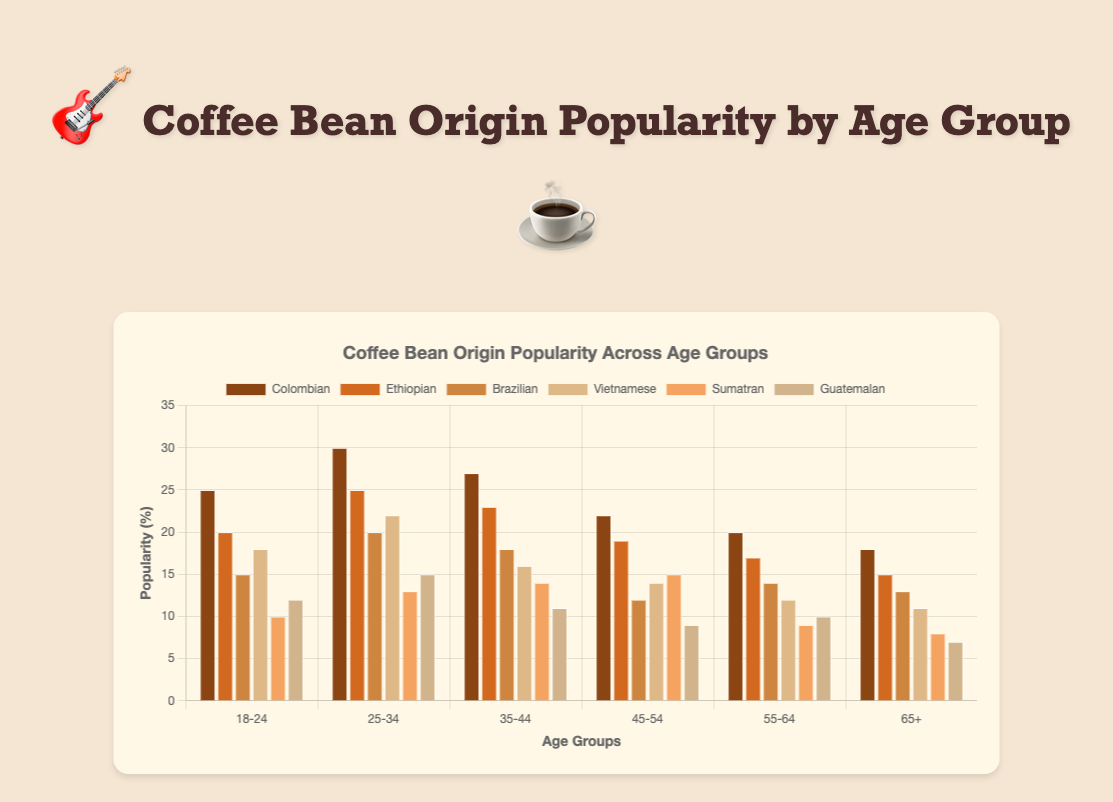Which age group favors Colombian coffee beans the most? By visually inspecting the bar heights corresponding to "Colombian" coffee beans across all age groups, the highest bar is observed in the "25-34" age group.
Answer: 25-34 Which coffee bean origin is the least popular among the 65+ age group? By comparing the heights of all bars in the "65+" category, the shortest bar corresponds to "Guatemalan".
Answer: Guatemalan Which coffee bean origin shows a decreasing trend in popularity across age groups? By observing the bars for each coffee bean origin, "Colombian" displays a consistent decrease in bar height from younger to older age groups.
Answer: Colombian For the "18-24" age group, what's the difference in popularity between Ethiopian and Brazilian coffee beans? The popularity of Ethiopian beans is 20%, and for Brazilian beans, it's 15%. The difference is calculated as 20% - 15% = 5%.
Answer: 5% Summing up the popularity percentages of Brazilian coffee beans for all age groups, what is the total? Add the values for Brazilian beans across all age groups: 15 + 20 + 18 + 12 + 14 + 13 = 92.
Answer: 92 Which coffee bean origin has the highest average popularity across all age groups? To find the average popularity for each origin: 
Colombian: (25 + 30 + 27 + 22 + 20 + 18)/6 = 23.67, 
Ethiopian: (20 + 25 + 23 + 19 + 17 + 15)/6 = 19.83,
Brazilian: (15 + 20 + 18 + 12 + 14 + 13)/6 = 15.33,
Vietnamese: (18 + 22 + 16 + 14 + 12 + 11)/6 = 15.50,
Sumatran: (10 + 13 + 14 + 15 + 9 + 8)/6 = 11.50,
Guatemalan: (12 + 15 + 11 + 9 + 10 + 7)/6 = 10.67.
Colombian has the highest average of 23.67.
Answer: Colombian What is the sum of the popularity of Guatemalan beans for the "35-44" and "55-64" age groups? The popularity values are 11% for "35-44" and 10% for "55-64". The sum is 11% + 10% = 21%.
Answer: 21 Is the popularity of Sumatran beans higher than Guatemalan beans in the "25-34" age group? By comparing the bar heights in the "25-34" category, Sumatran (13%) is less than Guatemalan (15%).
Answer: No Which age group shows the most balanced popularity among all coffee bean origins (i.e., smallest range between highest and lowest popularity)? Calculate the range (highest - lowest) for each age group:
18-24: 25-10=15,
25-34: 30-13=17,
35-44: 27-11=16,
45-54: 22-9=13,
55-64: 20-9=11,
65+: 18-7=11.
The smallest range is for the "55-64" and "65+" age groups with a range of 11.
Answer: 55-64 and 65+ What's the overall distribution pattern of Vietnamese coffee beans across age groups? Vietnamese coffee beans have a higher popularity in younger age groups with a declining trend as the age increases: 
 18-24: 18%, 25-34: 22%, 35-44: 16%, 45-54: 14%, 55-64: 12%, 65+: 11%.
Answer: Declining trend 